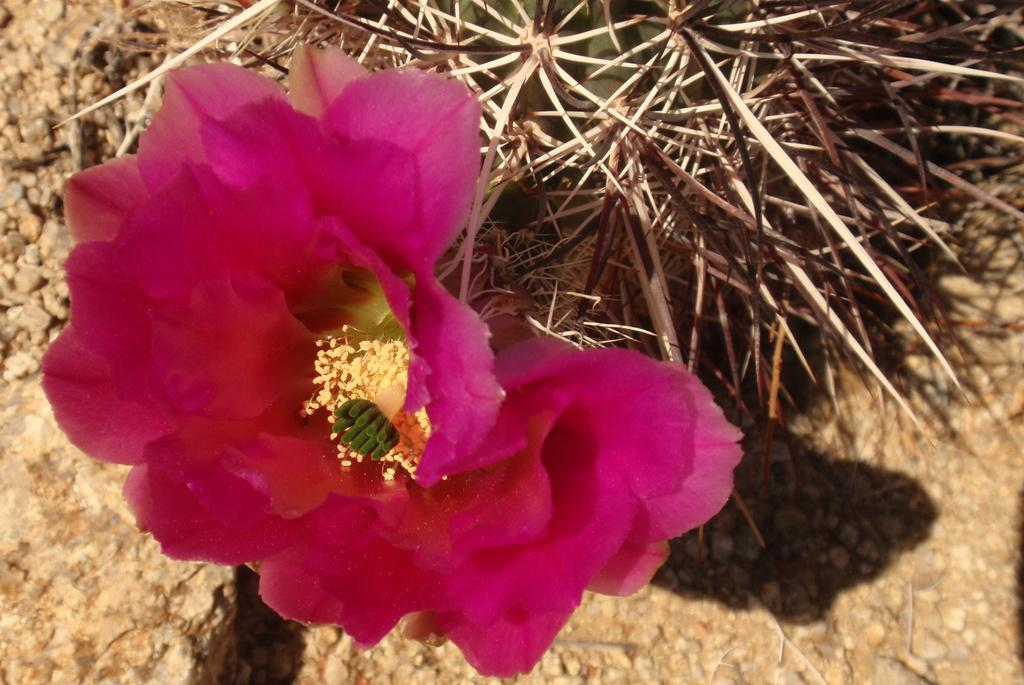What is the main subject in the foreground of the picture? There is a flower in the foreground of the picture. What color is the flower? The flower is pink in color. What can be seen at the top of the image? There are thorns of a tree at the top of the image. What is visible at the bottom of the image? Soil is visible at the bottom of the image. What is the name of the ant that is crawling on the flower in the image? There is no ant present in the image, so it is not possible to determine the name of an ant that is not there. 